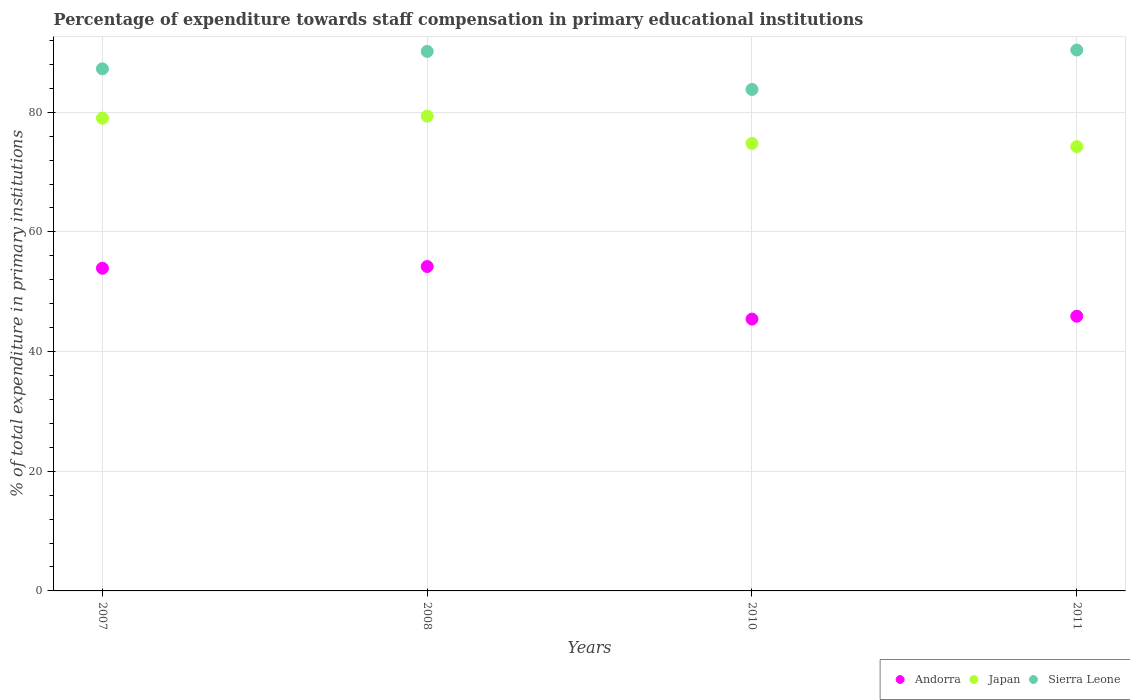How many different coloured dotlines are there?
Ensure brevity in your answer.  3. Is the number of dotlines equal to the number of legend labels?
Provide a succinct answer. Yes. What is the percentage of expenditure towards staff compensation in Japan in 2007?
Provide a succinct answer. 79.01. Across all years, what is the maximum percentage of expenditure towards staff compensation in Japan?
Provide a succinct answer. 79.35. Across all years, what is the minimum percentage of expenditure towards staff compensation in Andorra?
Make the answer very short. 45.43. What is the total percentage of expenditure towards staff compensation in Andorra in the graph?
Offer a very short reply. 199.5. What is the difference between the percentage of expenditure towards staff compensation in Andorra in 2007 and that in 2010?
Your answer should be compact. 8.5. What is the difference between the percentage of expenditure towards staff compensation in Japan in 2011 and the percentage of expenditure towards staff compensation in Sierra Leone in 2008?
Give a very brief answer. -15.91. What is the average percentage of expenditure towards staff compensation in Sierra Leone per year?
Offer a terse response. 87.91. In the year 2008, what is the difference between the percentage of expenditure towards staff compensation in Sierra Leone and percentage of expenditure towards staff compensation in Andorra?
Ensure brevity in your answer.  35.95. What is the ratio of the percentage of expenditure towards staff compensation in Sierra Leone in 2007 to that in 2008?
Offer a terse response. 0.97. Is the percentage of expenditure towards staff compensation in Japan in 2010 less than that in 2011?
Your response must be concise. No. Is the difference between the percentage of expenditure towards staff compensation in Sierra Leone in 2008 and 2011 greater than the difference between the percentage of expenditure towards staff compensation in Andorra in 2008 and 2011?
Make the answer very short. No. What is the difference between the highest and the second highest percentage of expenditure towards staff compensation in Andorra?
Ensure brevity in your answer.  0.28. What is the difference between the highest and the lowest percentage of expenditure towards staff compensation in Japan?
Your response must be concise. 5.1. Is it the case that in every year, the sum of the percentage of expenditure towards staff compensation in Andorra and percentage of expenditure towards staff compensation in Japan  is greater than the percentage of expenditure towards staff compensation in Sierra Leone?
Your response must be concise. Yes. Does the percentage of expenditure towards staff compensation in Japan monotonically increase over the years?
Offer a terse response. No. Is the percentage of expenditure towards staff compensation in Japan strictly greater than the percentage of expenditure towards staff compensation in Sierra Leone over the years?
Offer a very short reply. No. Is the percentage of expenditure towards staff compensation in Sierra Leone strictly less than the percentage of expenditure towards staff compensation in Japan over the years?
Your answer should be compact. No. What is the difference between two consecutive major ticks on the Y-axis?
Your answer should be very brief. 20. Are the values on the major ticks of Y-axis written in scientific E-notation?
Your answer should be compact. No. Does the graph contain grids?
Give a very brief answer. Yes. How are the legend labels stacked?
Keep it short and to the point. Horizontal. What is the title of the graph?
Give a very brief answer. Percentage of expenditure towards staff compensation in primary educational institutions. What is the label or title of the Y-axis?
Provide a short and direct response. % of total expenditure in primary institutions. What is the % of total expenditure in primary institutions of Andorra in 2007?
Provide a short and direct response. 53.93. What is the % of total expenditure in primary institutions of Japan in 2007?
Offer a very short reply. 79.01. What is the % of total expenditure in primary institutions of Sierra Leone in 2007?
Keep it short and to the point. 87.26. What is the % of total expenditure in primary institutions in Andorra in 2008?
Provide a succinct answer. 54.22. What is the % of total expenditure in primary institutions in Japan in 2008?
Ensure brevity in your answer.  79.35. What is the % of total expenditure in primary institutions in Sierra Leone in 2008?
Make the answer very short. 90.17. What is the % of total expenditure in primary institutions of Andorra in 2010?
Offer a very short reply. 45.43. What is the % of total expenditure in primary institutions of Japan in 2010?
Offer a terse response. 74.79. What is the % of total expenditure in primary institutions of Sierra Leone in 2010?
Provide a succinct answer. 83.81. What is the % of total expenditure in primary institutions of Andorra in 2011?
Provide a short and direct response. 45.91. What is the % of total expenditure in primary institutions in Japan in 2011?
Make the answer very short. 74.26. What is the % of total expenditure in primary institutions of Sierra Leone in 2011?
Give a very brief answer. 90.4. Across all years, what is the maximum % of total expenditure in primary institutions in Andorra?
Ensure brevity in your answer.  54.22. Across all years, what is the maximum % of total expenditure in primary institutions in Japan?
Keep it short and to the point. 79.35. Across all years, what is the maximum % of total expenditure in primary institutions of Sierra Leone?
Offer a terse response. 90.4. Across all years, what is the minimum % of total expenditure in primary institutions in Andorra?
Provide a succinct answer. 45.43. Across all years, what is the minimum % of total expenditure in primary institutions in Japan?
Make the answer very short. 74.26. Across all years, what is the minimum % of total expenditure in primary institutions in Sierra Leone?
Offer a very short reply. 83.81. What is the total % of total expenditure in primary institutions of Andorra in the graph?
Give a very brief answer. 199.5. What is the total % of total expenditure in primary institutions of Japan in the graph?
Offer a terse response. 307.41. What is the total % of total expenditure in primary institutions of Sierra Leone in the graph?
Provide a short and direct response. 351.64. What is the difference between the % of total expenditure in primary institutions of Andorra in 2007 and that in 2008?
Provide a succinct answer. -0.28. What is the difference between the % of total expenditure in primary institutions in Japan in 2007 and that in 2008?
Make the answer very short. -0.34. What is the difference between the % of total expenditure in primary institutions in Sierra Leone in 2007 and that in 2008?
Offer a terse response. -2.91. What is the difference between the % of total expenditure in primary institutions of Andorra in 2007 and that in 2010?
Your answer should be compact. 8.5. What is the difference between the % of total expenditure in primary institutions of Japan in 2007 and that in 2010?
Keep it short and to the point. 4.23. What is the difference between the % of total expenditure in primary institutions in Sierra Leone in 2007 and that in 2010?
Your answer should be compact. 3.45. What is the difference between the % of total expenditure in primary institutions of Andorra in 2007 and that in 2011?
Offer a terse response. 8.02. What is the difference between the % of total expenditure in primary institutions in Japan in 2007 and that in 2011?
Give a very brief answer. 4.76. What is the difference between the % of total expenditure in primary institutions in Sierra Leone in 2007 and that in 2011?
Make the answer very short. -3.14. What is the difference between the % of total expenditure in primary institutions of Andorra in 2008 and that in 2010?
Provide a short and direct response. 8.78. What is the difference between the % of total expenditure in primary institutions in Japan in 2008 and that in 2010?
Ensure brevity in your answer.  4.57. What is the difference between the % of total expenditure in primary institutions in Sierra Leone in 2008 and that in 2010?
Your answer should be very brief. 6.36. What is the difference between the % of total expenditure in primary institutions of Andorra in 2008 and that in 2011?
Your answer should be very brief. 8.3. What is the difference between the % of total expenditure in primary institutions of Japan in 2008 and that in 2011?
Make the answer very short. 5.1. What is the difference between the % of total expenditure in primary institutions in Sierra Leone in 2008 and that in 2011?
Provide a short and direct response. -0.23. What is the difference between the % of total expenditure in primary institutions in Andorra in 2010 and that in 2011?
Make the answer very short. -0.48. What is the difference between the % of total expenditure in primary institutions in Japan in 2010 and that in 2011?
Your response must be concise. 0.53. What is the difference between the % of total expenditure in primary institutions of Sierra Leone in 2010 and that in 2011?
Offer a very short reply. -6.59. What is the difference between the % of total expenditure in primary institutions in Andorra in 2007 and the % of total expenditure in primary institutions in Japan in 2008?
Ensure brevity in your answer.  -25.42. What is the difference between the % of total expenditure in primary institutions of Andorra in 2007 and the % of total expenditure in primary institutions of Sierra Leone in 2008?
Make the answer very short. -36.24. What is the difference between the % of total expenditure in primary institutions of Japan in 2007 and the % of total expenditure in primary institutions of Sierra Leone in 2008?
Keep it short and to the point. -11.15. What is the difference between the % of total expenditure in primary institutions in Andorra in 2007 and the % of total expenditure in primary institutions in Japan in 2010?
Make the answer very short. -20.85. What is the difference between the % of total expenditure in primary institutions of Andorra in 2007 and the % of total expenditure in primary institutions of Sierra Leone in 2010?
Make the answer very short. -29.88. What is the difference between the % of total expenditure in primary institutions of Japan in 2007 and the % of total expenditure in primary institutions of Sierra Leone in 2010?
Keep it short and to the point. -4.8. What is the difference between the % of total expenditure in primary institutions in Andorra in 2007 and the % of total expenditure in primary institutions in Japan in 2011?
Keep it short and to the point. -20.32. What is the difference between the % of total expenditure in primary institutions in Andorra in 2007 and the % of total expenditure in primary institutions in Sierra Leone in 2011?
Offer a very short reply. -36.47. What is the difference between the % of total expenditure in primary institutions of Japan in 2007 and the % of total expenditure in primary institutions of Sierra Leone in 2011?
Your response must be concise. -11.39. What is the difference between the % of total expenditure in primary institutions of Andorra in 2008 and the % of total expenditure in primary institutions of Japan in 2010?
Your answer should be very brief. -20.57. What is the difference between the % of total expenditure in primary institutions in Andorra in 2008 and the % of total expenditure in primary institutions in Sierra Leone in 2010?
Your answer should be compact. -29.6. What is the difference between the % of total expenditure in primary institutions in Japan in 2008 and the % of total expenditure in primary institutions in Sierra Leone in 2010?
Provide a succinct answer. -4.46. What is the difference between the % of total expenditure in primary institutions of Andorra in 2008 and the % of total expenditure in primary institutions of Japan in 2011?
Ensure brevity in your answer.  -20.04. What is the difference between the % of total expenditure in primary institutions of Andorra in 2008 and the % of total expenditure in primary institutions of Sierra Leone in 2011?
Provide a succinct answer. -36.18. What is the difference between the % of total expenditure in primary institutions in Japan in 2008 and the % of total expenditure in primary institutions in Sierra Leone in 2011?
Give a very brief answer. -11.05. What is the difference between the % of total expenditure in primary institutions of Andorra in 2010 and the % of total expenditure in primary institutions of Japan in 2011?
Ensure brevity in your answer.  -28.82. What is the difference between the % of total expenditure in primary institutions in Andorra in 2010 and the % of total expenditure in primary institutions in Sierra Leone in 2011?
Ensure brevity in your answer.  -44.97. What is the difference between the % of total expenditure in primary institutions in Japan in 2010 and the % of total expenditure in primary institutions in Sierra Leone in 2011?
Make the answer very short. -15.61. What is the average % of total expenditure in primary institutions in Andorra per year?
Provide a succinct answer. 49.87. What is the average % of total expenditure in primary institutions in Japan per year?
Provide a succinct answer. 76.85. What is the average % of total expenditure in primary institutions of Sierra Leone per year?
Keep it short and to the point. 87.91. In the year 2007, what is the difference between the % of total expenditure in primary institutions of Andorra and % of total expenditure in primary institutions of Japan?
Make the answer very short. -25.08. In the year 2007, what is the difference between the % of total expenditure in primary institutions of Andorra and % of total expenditure in primary institutions of Sierra Leone?
Your response must be concise. -33.33. In the year 2007, what is the difference between the % of total expenditure in primary institutions in Japan and % of total expenditure in primary institutions in Sierra Leone?
Provide a short and direct response. -8.24. In the year 2008, what is the difference between the % of total expenditure in primary institutions in Andorra and % of total expenditure in primary institutions in Japan?
Provide a short and direct response. -25.14. In the year 2008, what is the difference between the % of total expenditure in primary institutions in Andorra and % of total expenditure in primary institutions in Sierra Leone?
Ensure brevity in your answer.  -35.95. In the year 2008, what is the difference between the % of total expenditure in primary institutions of Japan and % of total expenditure in primary institutions of Sierra Leone?
Provide a succinct answer. -10.81. In the year 2010, what is the difference between the % of total expenditure in primary institutions of Andorra and % of total expenditure in primary institutions of Japan?
Make the answer very short. -29.35. In the year 2010, what is the difference between the % of total expenditure in primary institutions in Andorra and % of total expenditure in primary institutions in Sierra Leone?
Your answer should be very brief. -38.38. In the year 2010, what is the difference between the % of total expenditure in primary institutions of Japan and % of total expenditure in primary institutions of Sierra Leone?
Give a very brief answer. -9.02. In the year 2011, what is the difference between the % of total expenditure in primary institutions of Andorra and % of total expenditure in primary institutions of Japan?
Your answer should be compact. -28.34. In the year 2011, what is the difference between the % of total expenditure in primary institutions of Andorra and % of total expenditure in primary institutions of Sierra Leone?
Your response must be concise. -44.49. In the year 2011, what is the difference between the % of total expenditure in primary institutions in Japan and % of total expenditure in primary institutions in Sierra Leone?
Provide a short and direct response. -16.14. What is the ratio of the % of total expenditure in primary institutions in Sierra Leone in 2007 to that in 2008?
Your answer should be very brief. 0.97. What is the ratio of the % of total expenditure in primary institutions in Andorra in 2007 to that in 2010?
Your answer should be very brief. 1.19. What is the ratio of the % of total expenditure in primary institutions of Japan in 2007 to that in 2010?
Keep it short and to the point. 1.06. What is the ratio of the % of total expenditure in primary institutions in Sierra Leone in 2007 to that in 2010?
Your response must be concise. 1.04. What is the ratio of the % of total expenditure in primary institutions of Andorra in 2007 to that in 2011?
Keep it short and to the point. 1.17. What is the ratio of the % of total expenditure in primary institutions in Japan in 2007 to that in 2011?
Provide a short and direct response. 1.06. What is the ratio of the % of total expenditure in primary institutions of Sierra Leone in 2007 to that in 2011?
Your answer should be compact. 0.97. What is the ratio of the % of total expenditure in primary institutions of Andorra in 2008 to that in 2010?
Your answer should be compact. 1.19. What is the ratio of the % of total expenditure in primary institutions in Japan in 2008 to that in 2010?
Give a very brief answer. 1.06. What is the ratio of the % of total expenditure in primary institutions in Sierra Leone in 2008 to that in 2010?
Provide a succinct answer. 1.08. What is the ratio of the % of total expenditure in primary institutions in Andorra in 2008 to that in 2011?
Make the answer very short. 1.18. What is the ratio of the % of total expenditure in primary institutions in Japan in 2008 to that in 2011?
Ensure brevity in your answer.  1.07. What is the ratio of the % of total expenditure in primary institutions of Japan in 2010 to that in 2011?
Ensure brevity in your answer.  1.01. What is the ratio of the % of total expenditure in primary institutions in Sierra Leone in 2010 to that in 2011?
Offer a terse response. 0.93. What is the difference between the highest and the second highest % of total expenditure in primary institutions of Andorra?
Provide a succinct answer. 0.28. What is the difference between the highest and the second highest % of total expenditure in primary institutions of Japan?
Offer a very short reply. 0.34. What is the difference between the highest and the second highest % of total expenditure in primary institutions of Sierra Leone?
Give a very brief answer. 0.23. What is the difference between the highest and the lowest % of total expenditure in primary institutions of Andorra?
Provide a succinct answer. 8.78. What is the difference between the highest and the lowest % of total expenditure in primary institutions of Japan?
Offer a very short reply. 5.1. What is the difference between the highest and the lowest % of total expenditure in primary institutions of Sierra Leone?
Offer a very short reply. 6.59. 